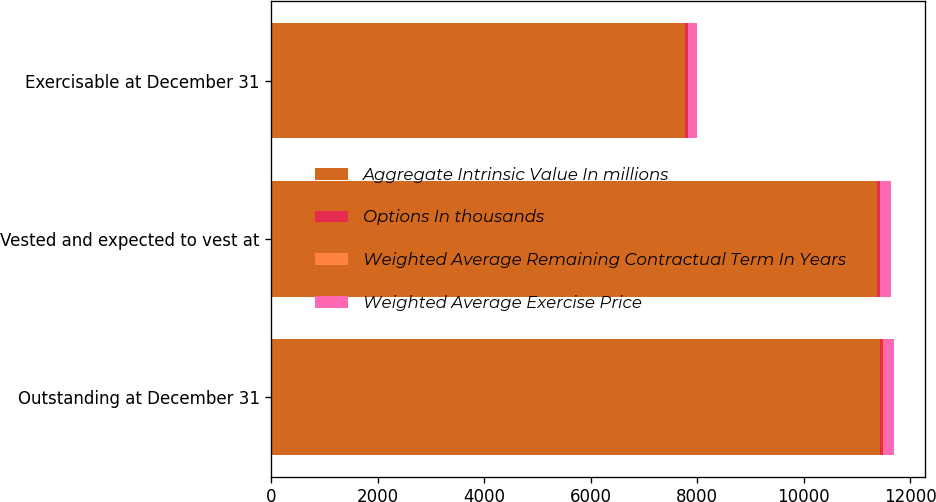<chart> <loc_0><loc_0><loc_500><loc_500><stacked_bar_chart><ecel><fcel>Outstanding at December 31<fcel>Vested and expected to vest at<fcel>Exercisable at December 31<nl><fcel>Aggregate Intrinsic Value In millions<fcel>11434<fcel>11369<fcel>7768<nl><fcel>Options In thousands<fcel>62.64<fcel>62.59<fcel>59.63<nl><fcel>Weighted Average Remaining Contractual Term In Years<fcel>3.8<fcel>3.8<fcel>2.7<nl><fcel>Weighted Average Exercise Price<fcel>201<fcel>200<fcel>164<nl></chart> 